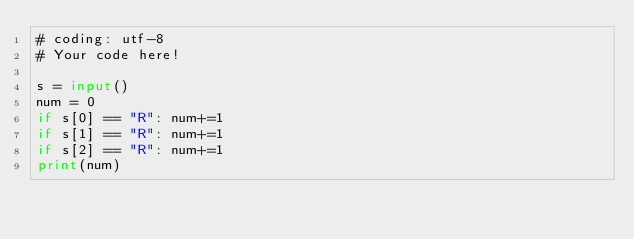Convert code to text. <code><loc_0><loc_0><loc_500><loc_500><_Python_># coding: utf-8
# Your code here!

s = input()
num = 0
if s[0] == "R": num+=1
if s[1] == "R": num+=1
if s[2] == "R": num+=1
print(num)</code> 